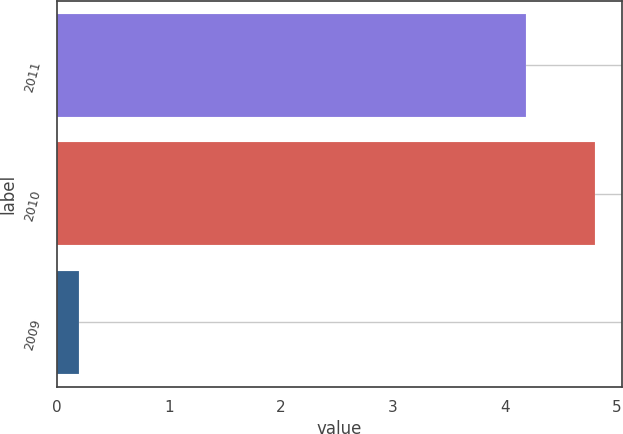Convert chart. <chart><loc_0><loc_0><loc_500><loc_500><bar_chart><fcel>2011<fcel>2010<fcel>2009<nl><fcel>4.19<fcel>4.81<fcel>0.2<nl></chart> 